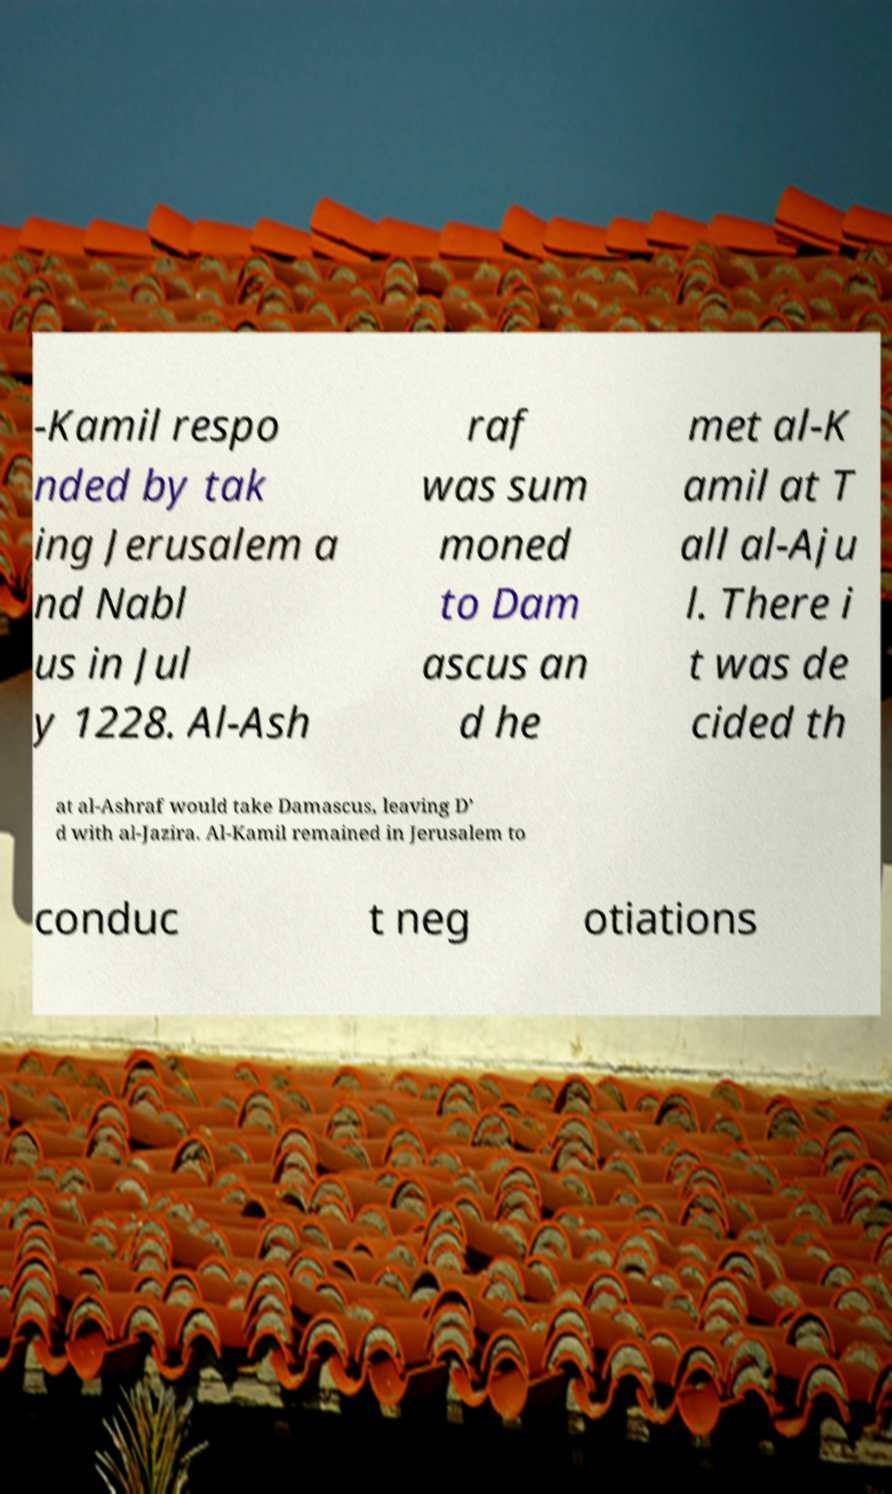Can you accurately transcribe the text from the provided image for me? -Kamil respo nded by tak ing Jerusalem a nd Nabl us in Jul y 1228. Al-Ash raf was sum moned to Dam ascus an d he met al-K amil at T all al-Aju l. There i t was de cided th at al-Ashraf would take Damascus, leaving D’ d with al-Jazira. Al-Kamil remained in Jerusalem to conduc t neg otiations 